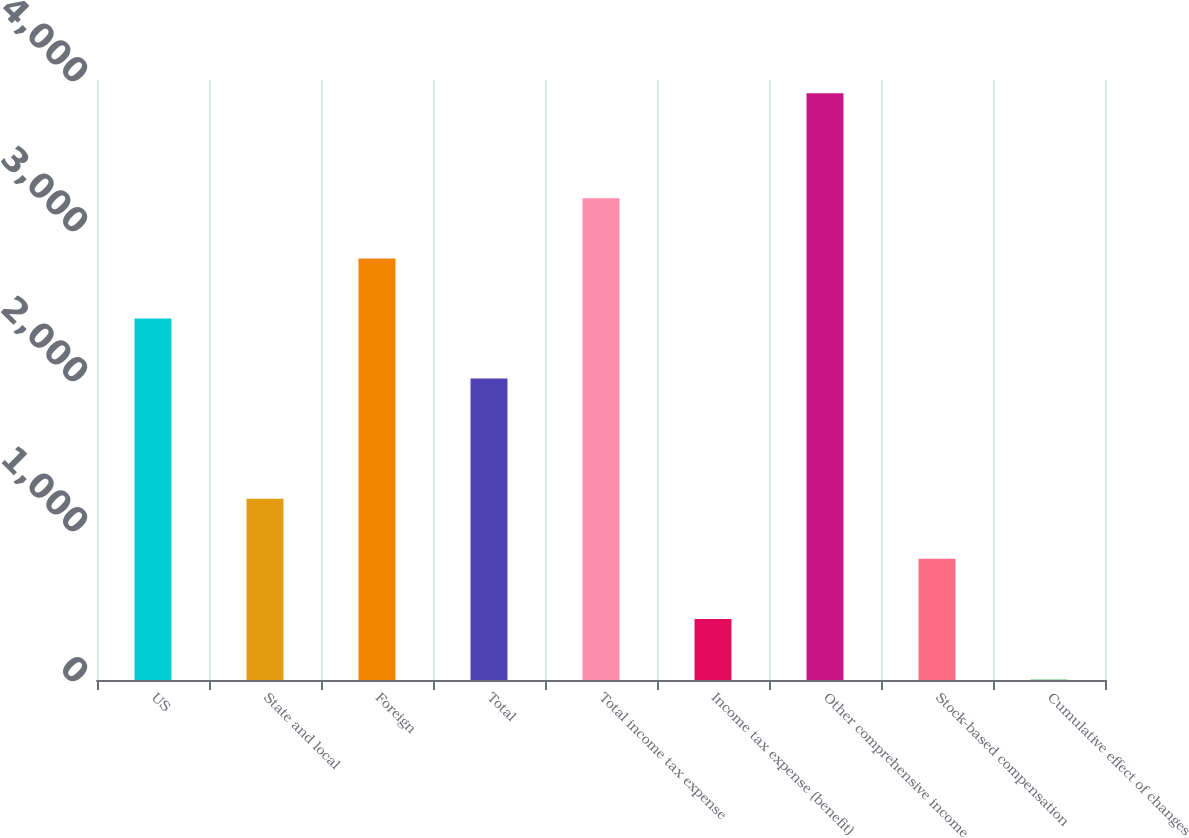Convert chart. <chart><loc_0><loc_0><loc_500><loc_500><bar_chart><fcel>US<fcel>State and local<fcel>Foreign<fcel>Total<fcel>Total income tax expense<fcel>Income tax expense (benefit)<fcel>Other comprehensive income<fcel>Stock-based compensation<fcel>Cumulative effect of changes<nl><fcel>2410<fcel>1208.5<fcel>2810.5<fcel>2009.5<fcel>3211<fcel>407.5<fcel>3912<fcel>808<fcel>7<nl></chart> 